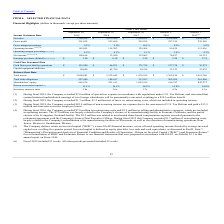According to Plexus's financial document, What was the amount of special tax expense in accordance with regulations under U.S. Tax Reform during Fiscal 2019? According to the financial document, 7.0 (in millions). The relevant text states: "(1) During fiscal 2019, the Company recorded $7.0 million of special tax expense in accordance with regulations under U.S. Tax Reform, and reasserted..." Also, What was the net sales in 2015? According to the financial document, 2,654,290 (in thousands). The relevant text states: "$ 3,164,434 $ 2,873,508 $ 2,528,052 $ 2,556,004 $ 2,654,290..." Also, Which years does the table provide information for the company's financial highlights? The document contains multiple relevant values: 2019, 2018, 2017, 2016, 2015. From the document: "2018 2019 2016 2015 (6) 2017..." Also, How many years did the gross margin percentage exceed 10%? Based on the analysis, there are 1 instances. The counting process: 2017. Also, can you calculate: What was the change in the gross profit between 2015 and 2016? Based on the calculation: 227,359-239,550, the result is -12191 (in thousands). This is based on the information: "Gross profit 291,838 257,600 255,855 227,359 239,550 Gross profit 291,838 257,600 255,855 227,359 239,550..." The key data points involved are: 227,359, 239,550. Also, can you calculate: What was the percentage change in net income between 2018 and 2019? To answer this question, I need to perform calculations using the financial data. The calculation is: (108,616-13,040)/13,040, which equals 732.94 (percentage). This is based on the information: "Net income (1) (2) (3) (4) 108,616 13,040 112,062 76,427 94,332 Net income (1) (2) (3) (4) 108,616 13,040 112,062 76,427 94,332..." The key data points involved are: 108,616, 13,040. 